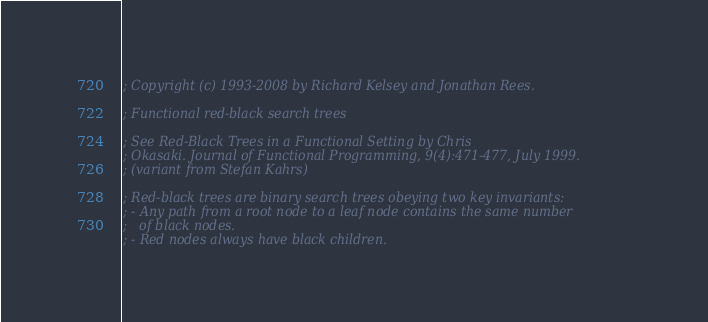Convert code to text. <code><loc_0><loc_0><loc_500><loc_500><_Scheme_>; Copyright (c) 1993-2008 by Richard Kelsey and Jonathan Rees.

; Functional red-black search trees

; See Red-Black Trees in a Functional Setting by Chris
; Okasaki. Journal of Functional Programming, 9(4):471-477, July 1999.
; (variant from Stefan Kahrs)

; Red-black trees are binary search trees obeying two key invariants:
; - Any path from a root node to a leaf node contains the same number
;   of black nodes.
; - Red nodes always have black children.
</code> 